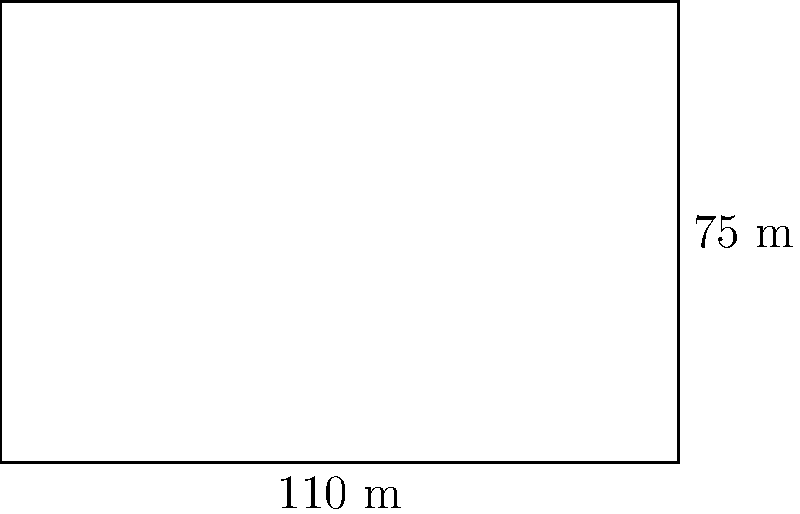As I gaze upon this magnificent football pitch, I'm reminded of our national team's recent victory! The field measures 110 meters in length and 75 meters in width. What's the approximate area of this glorious battlefield where our heroes showcase their skills? Let's break this down step-by-step, just like analyzing a game-winning play:

1) The shape of the football pitch is a rectangle.

2) The formula for the area of a rectangle is:
   $$A = l \times w$$
   where $A$ is the area, $l$ is the length, and $w$ is the width.

3) We're given:
   Length $(l) = 110$ meters
   Width $(w) = 75$ meters

4) Let's substitute these values into our formula:
   $$A = 110 \times 75$$

5) Now, let's multiply:
   $$A = 8,250 \text{ square meters}$$

6) Therefore, the area of the football pitch is 8,250 square meters.

What an impressive size for our athletes to display their talents!
Answer: 8,250 square meters 